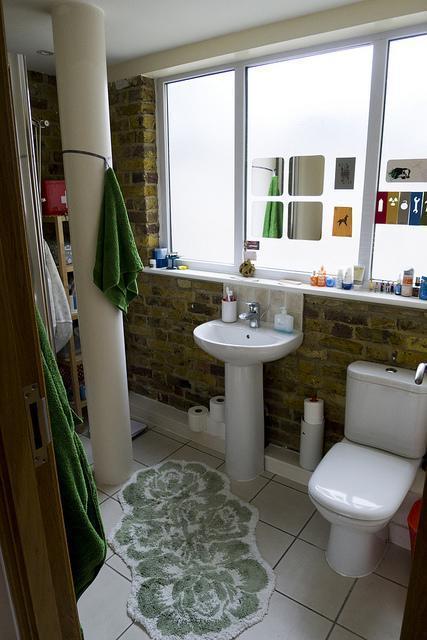How many vases are on the window sill?
Give a very brief answer. 0. How many people are in the picture?
Give a very brief answer. 0. 